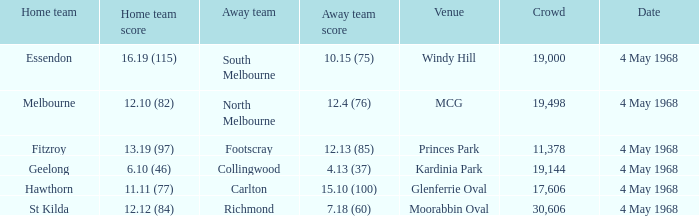How big was the crowd of the team that scored 4.13 (37)? 19144.0. 